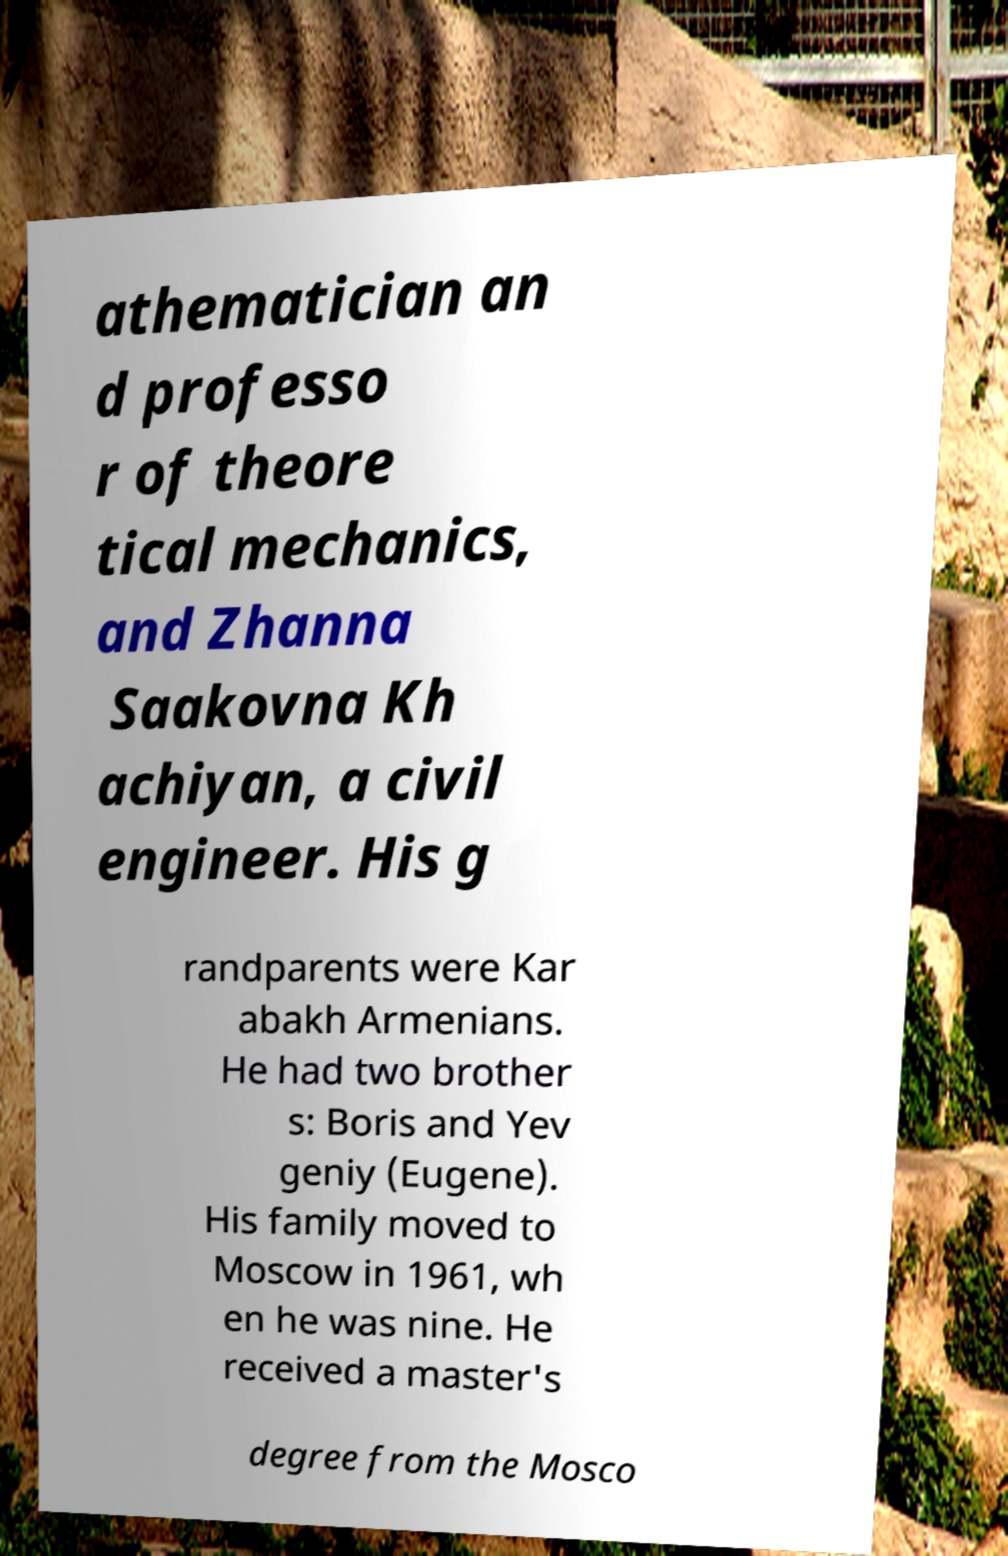What messages or text are displayed in this image? I need them in a readable, typed format. athematician an d professo r of theore tical mechanics, and Zhanna Saakovna Kh achiyan, a civil engineer. His g randparents were Kar abakh Armenians. He had two brother s: Boris and Yev geniy (Eugene). His family moved to Moscow in 1961, wh en he was nine. He received a master's degree from the Mosco 